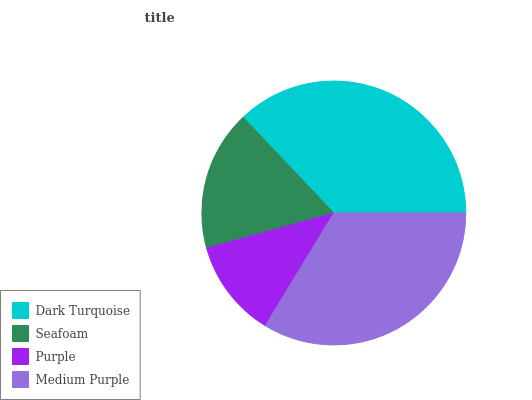Is Purple the minimum?
Answer yes or no. Yes. Is Dark Turquoise the maximum?
Answer yes or no. Yes. Is Seafoam the minimum?
Answer yes or no. No. Is Seafoam the maximum?
Answer yes or no. No. Is Dark Turquoise greater than Seafoam?
Answer yes or no. Yes. Is Seafoam less than Dark Turquoise?
Answer yes or no. Yes. Is Seafoam greater than Dark Turquoise?
Answer yes or no. No. Is Dark Turquoise less than Seafoam?
Answer yes or no. No. Is Medium Purple the high median?
Answer yes or no. Yes. Is Seafoam the low median?
Answer yes or no. Yes. Is Purple the high median?
Answer yes or no. No. Is Purple the low median?
Answer yes or no. No. 